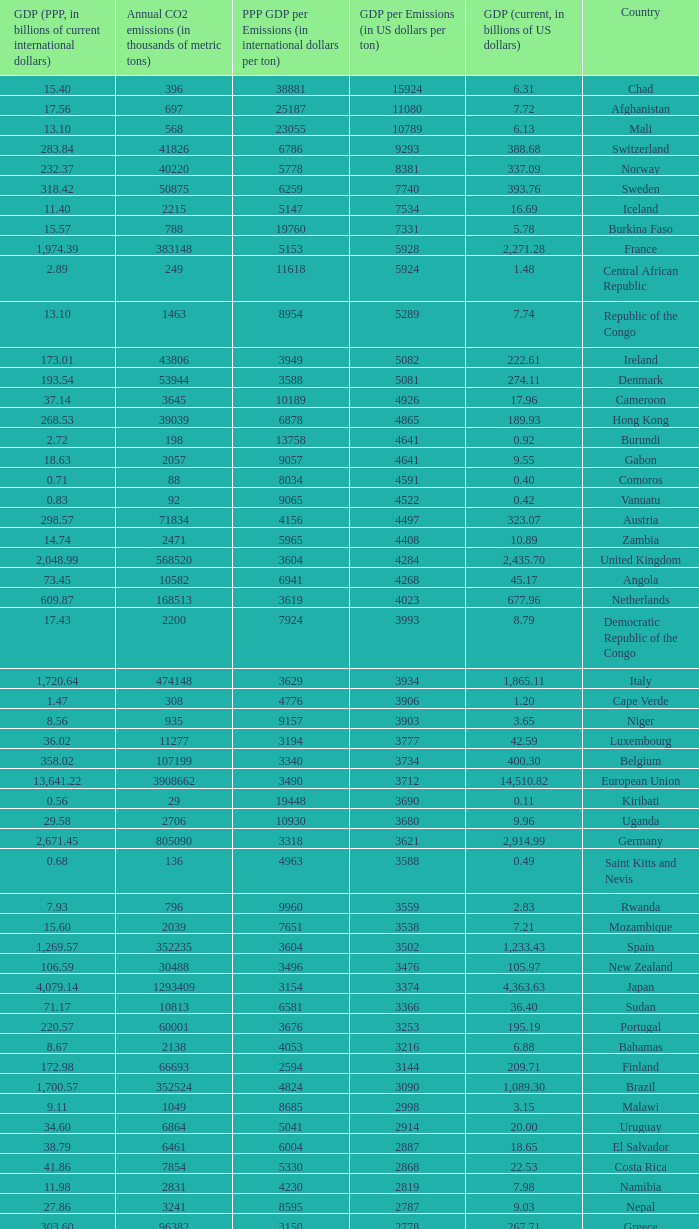When the annual co2 emissions (in thousands of metric tons) is 1811, what is the country? Haiti. 